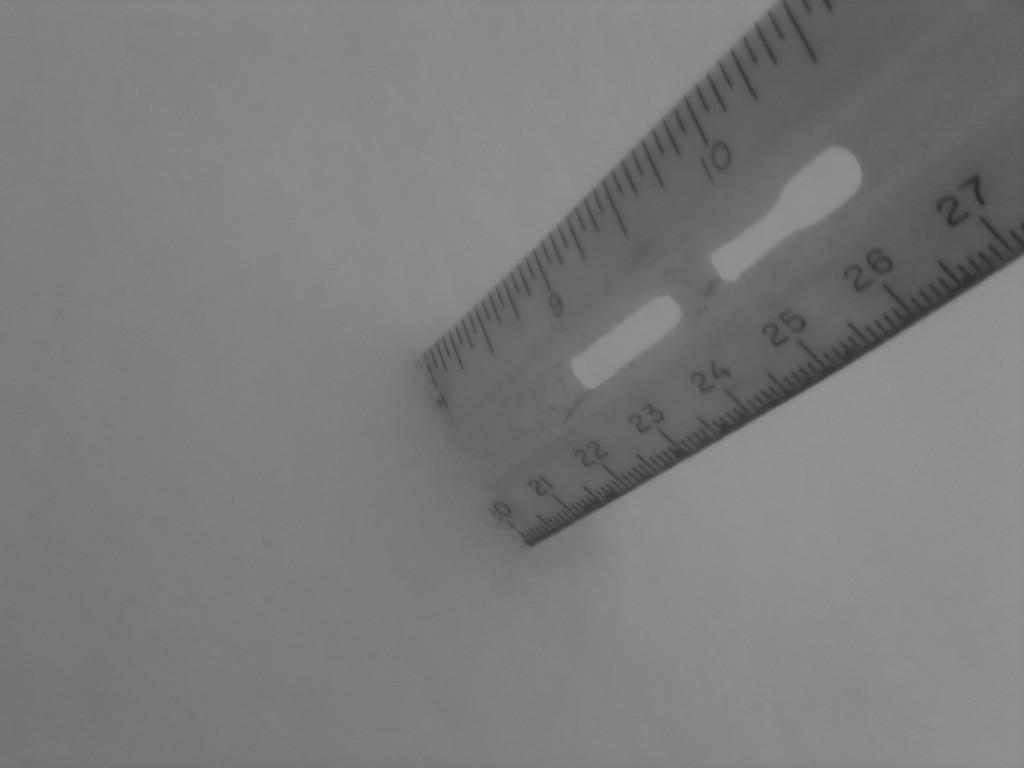<image>
Relay a brief, clear account of the picture shown. the bottom edge of a ruler the shows the 10 inch mark 